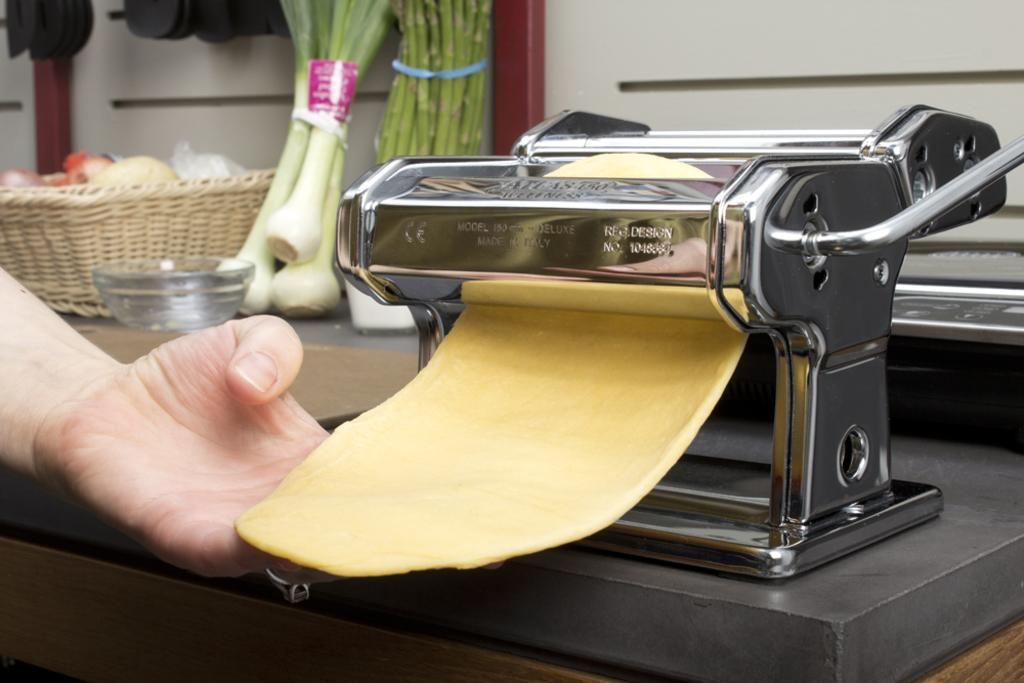<image>
Share a concise interpretation of the image provided. A pasta making machine sitting on a counter with Reg. Design on it. 